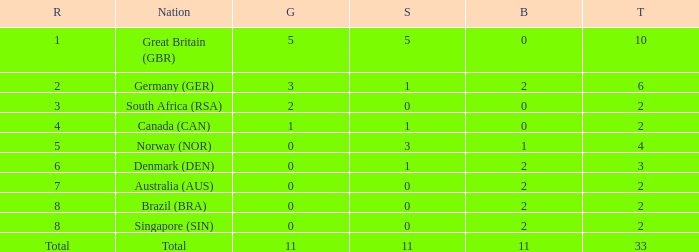What is the least total when the nation is canada (can) and bronze is less than 0? None. 